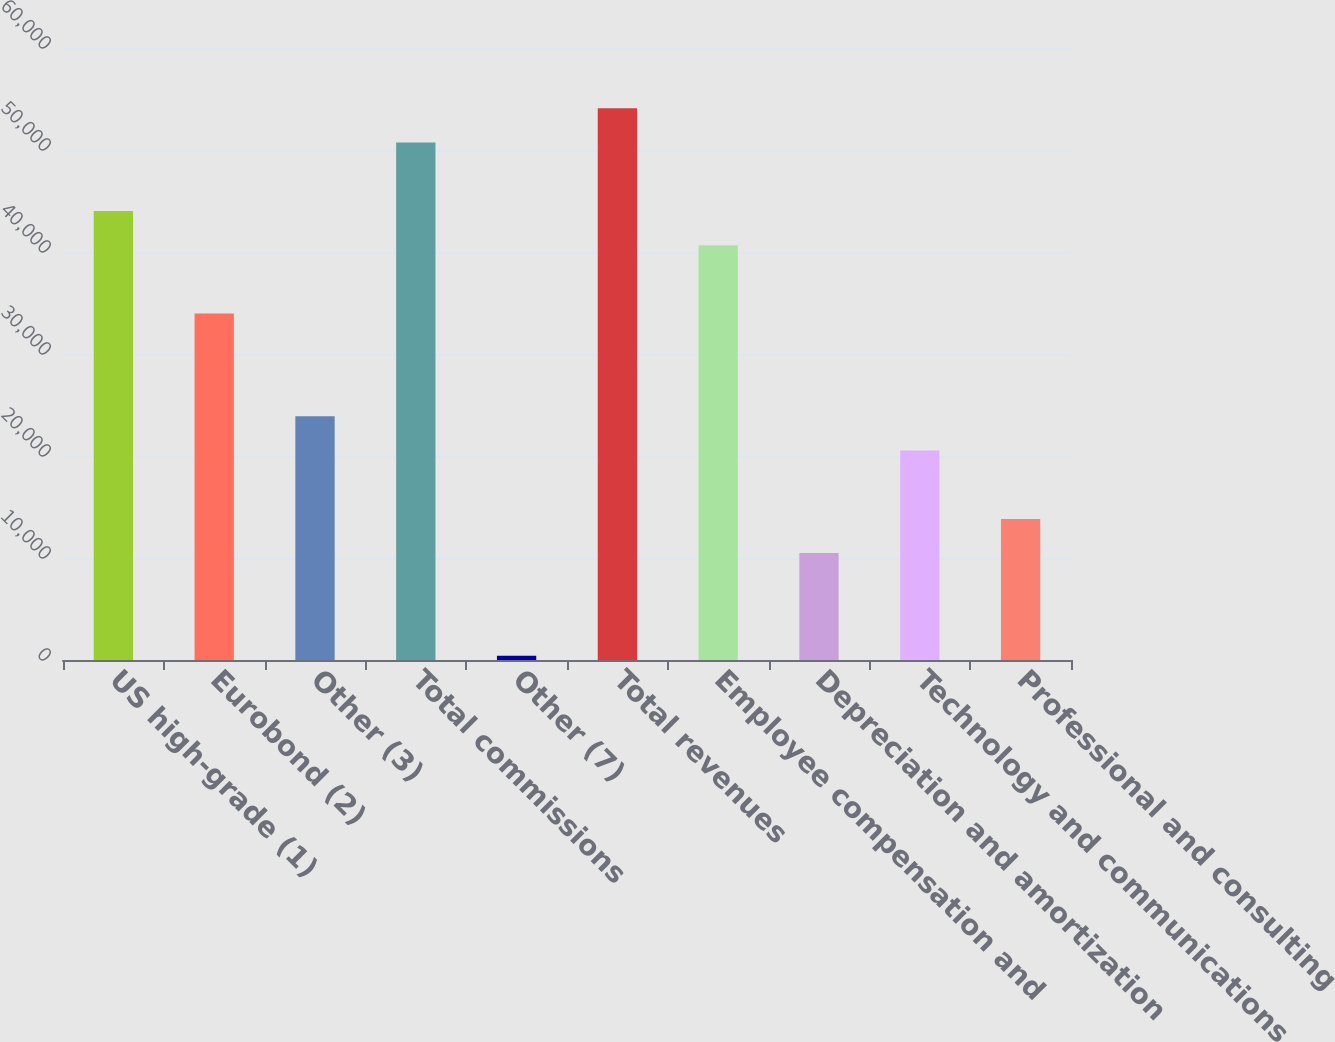<chart> <loc_0><loc_0><loc_500><loc_500><bar_chart><fcel>US high-grade (1)<fcel>Eurobond (2)<fcel>Other (3)<fcel>Total commissions<fcel>Other (7)<fcel>Total revenues<fcel>Employee compensation and<fcel>Depreciation and amortization<fcel>Technology and communications<fcel>Professional and consulting<nl><fcel>44021.3<fcel>33959<fcel>23896.7<fcel>50729.5<fcel>418<fcel>54083.6<fcel>40667.2<fcel>10480.3<fcel>20542.6<fcel>13834.4<nl></chart> 